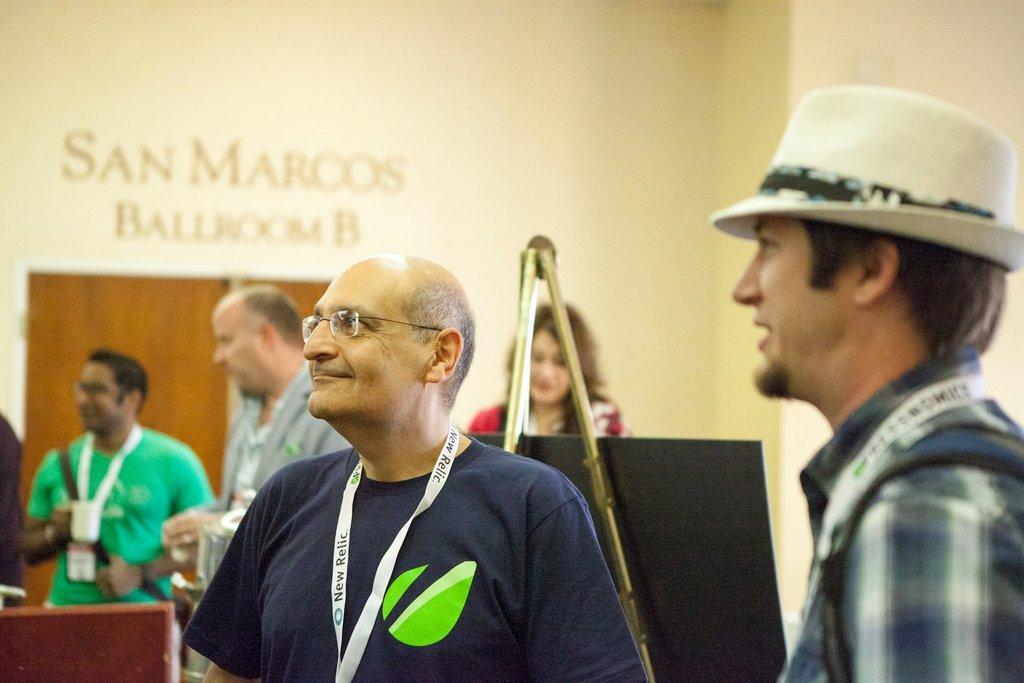Describe this image in one or two sentences. On the right we can see a person wearing hat. In the center there is a person standing. The background is blurred. In the background there are people, stand, board, door and wall. 